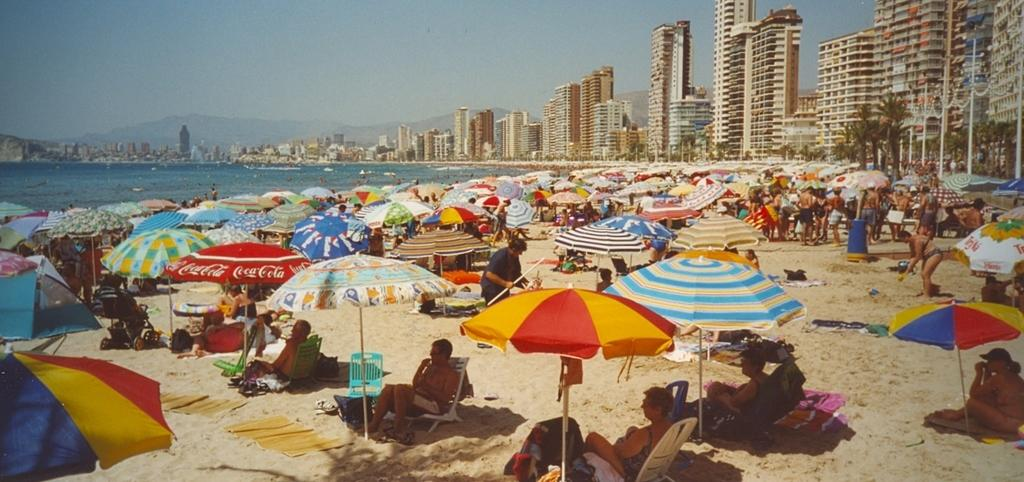What are the people in the image doing? The people in the image are sitting on chairs and the ground. What are the parasols used for in the image? The parasols are used to provide shade for the people sitting in the image. Where is the scene taking place? The scene takes place on a seashore. What architectural features can be seen in the image? Street poles, street lights, trees, buildings, and skyscrapers are visible in the image. What natural features can be seen in the image? Hills and the sea are visible in the image. What part of the sky is visible in the image? The sky is visible in the image. What type of animal can be seen celebrating its birthday in the image? There is no animal or birthday celebration present in the image. What is the color of the tongue of the person sitting on the ground in the image? There is no mention of a tongue or a specific person sitting on the ground in the image, so it cannot be determined. 